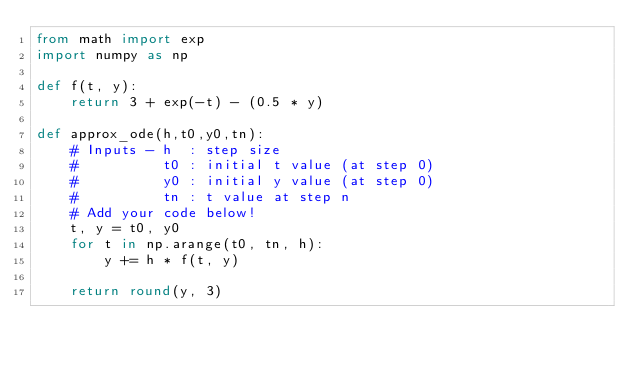<code> <loc_0><loc_0><loc_500><loc_500><_Python_>from math import exp
import numpy as np

def f(t, y):
    return 3 + exp(-t) - (0.5 * y)

def approx_ode(h,t0,y0,tn):
    # Inputs - h  : step size
    #          t0 : initial t value (at step 0)
    #          y0 : initial y value (at step 0)
    #          tn : t value at step n
    # Add your code below!
    t, y = t0, y0
    for t in np.arange(t0, tn, h):
        y += h * f(t, y)

    return round(y, 3)</code> 